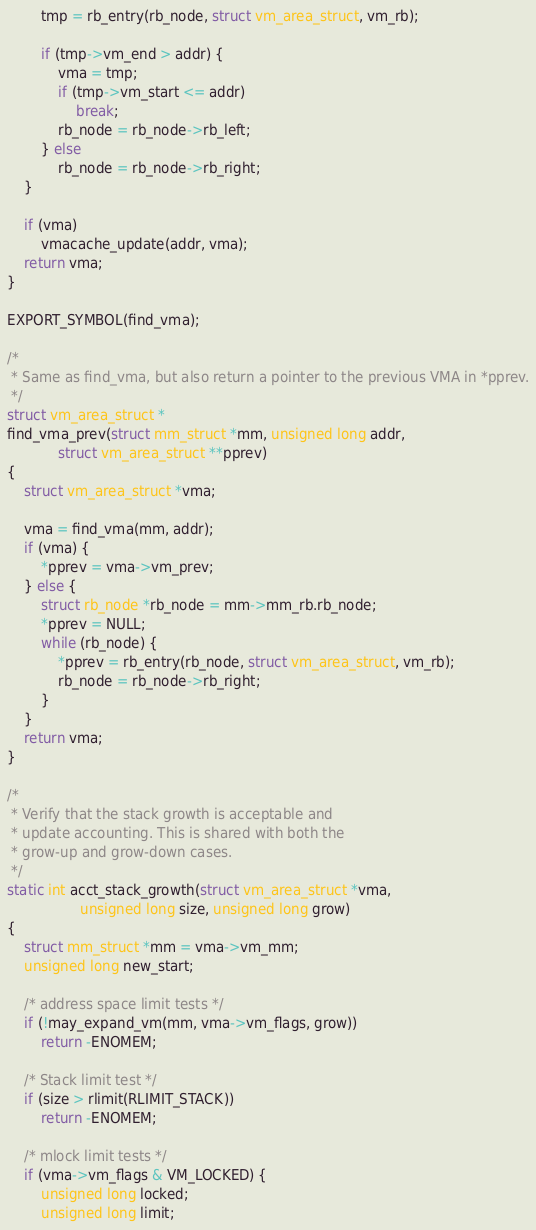Convert code to text. <code><loc_0><loc_0><loc_500><loc_500><_C_>
		tmp = rb_entry(rb_node, struct vm_area_struct, vm_rb);

		if (tmp->vm_end > addr) {
			vma = tmp;
			if (tmp->vm_start <= addr)
				break;
			rb_node = rb_node->rb_left;
		} else
			rb_node = rb_node->rb_right;
	}

	if (vma)
		vmacache_update(addr, vma);
	return vma;
}

EXPORT_SYMBOL(find_vma);

/*
 * Same as find_vma, but also return a pointer to the previous VMA in *pprev.
 */
struct vm_area_struct *
find_vma_prev(struct mm_struct *mm, unsigned long addr,
			struct vm_area_struct **pprev)
{
	struct vm_area_struct *vma;

	vma = find_vma(mm, addr);
	if (vma) {
		*pprev = vma->vm_prev;
	} else {
		struct rb_node *rb_node = mm->mm_rb.rb_node;
		*pprev = NULL;
		while (rb_node) {
			*pprev = rb_entry(rb_node, struct vm_area_struct, vm_rb);
			rb_node = rb_node->rb_right;
		}
	}
	return vma;
}

/*
 * Verify that the stack growth is acceptable and
 * update accounting. This is shared with both the
 * grow-up and grow-down cases.
 */
static int acct_stack_growth(struct vm_area_struct *vma,
			     unsigned long size, unsigned long grow)
{
	struct mm_struct *mm = vma->vm_mm;
	unsigned long new_start;

	/* address space limit tests */
	if (!may_expand_vm(mm, vma->vm_flags, grow))
		return -ENOMEM;

	/* Stack limit test */
	if (size > rlimit(RLIMIT_STACK))
		return -ENOMEM;

	/* mlock limit tests */
	if (vma->vm_flags & VM_LOCKED) {
		unsigned long locked;
		unsigned long limit;</code> 